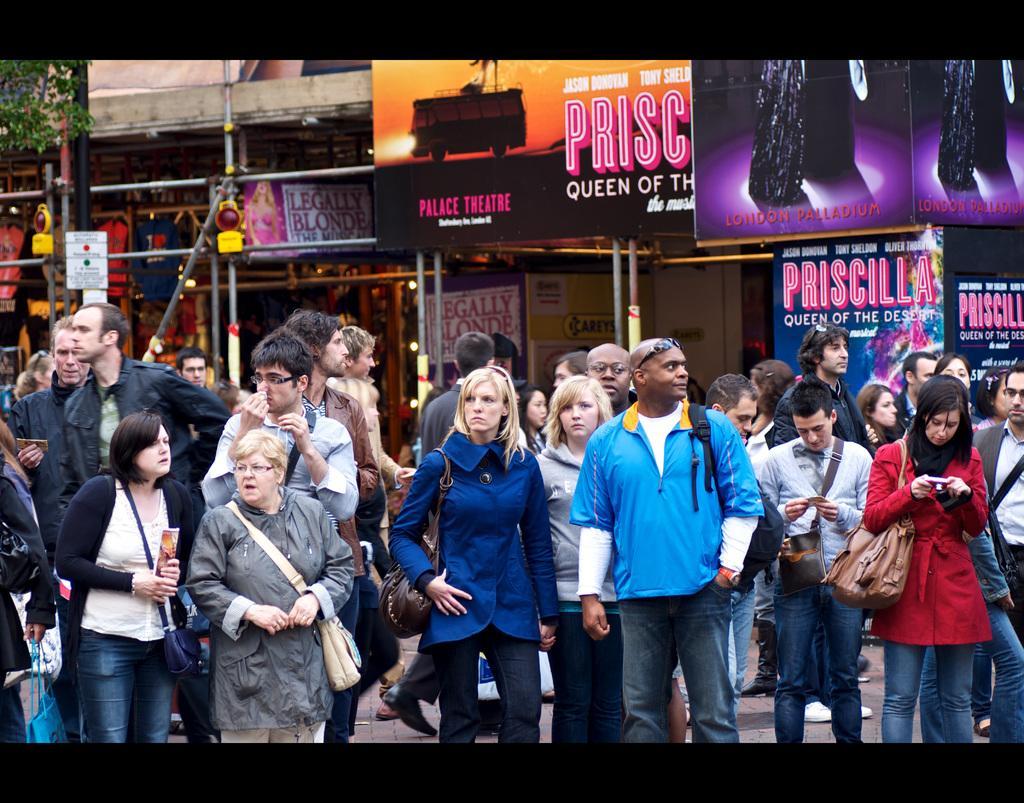Describe this image in one or two sentences. This is an edited image. I can see a group of people standing. In the background, there are hoardings, iron poles and clothes. At the top left corner of the image, I can see the leaves. 